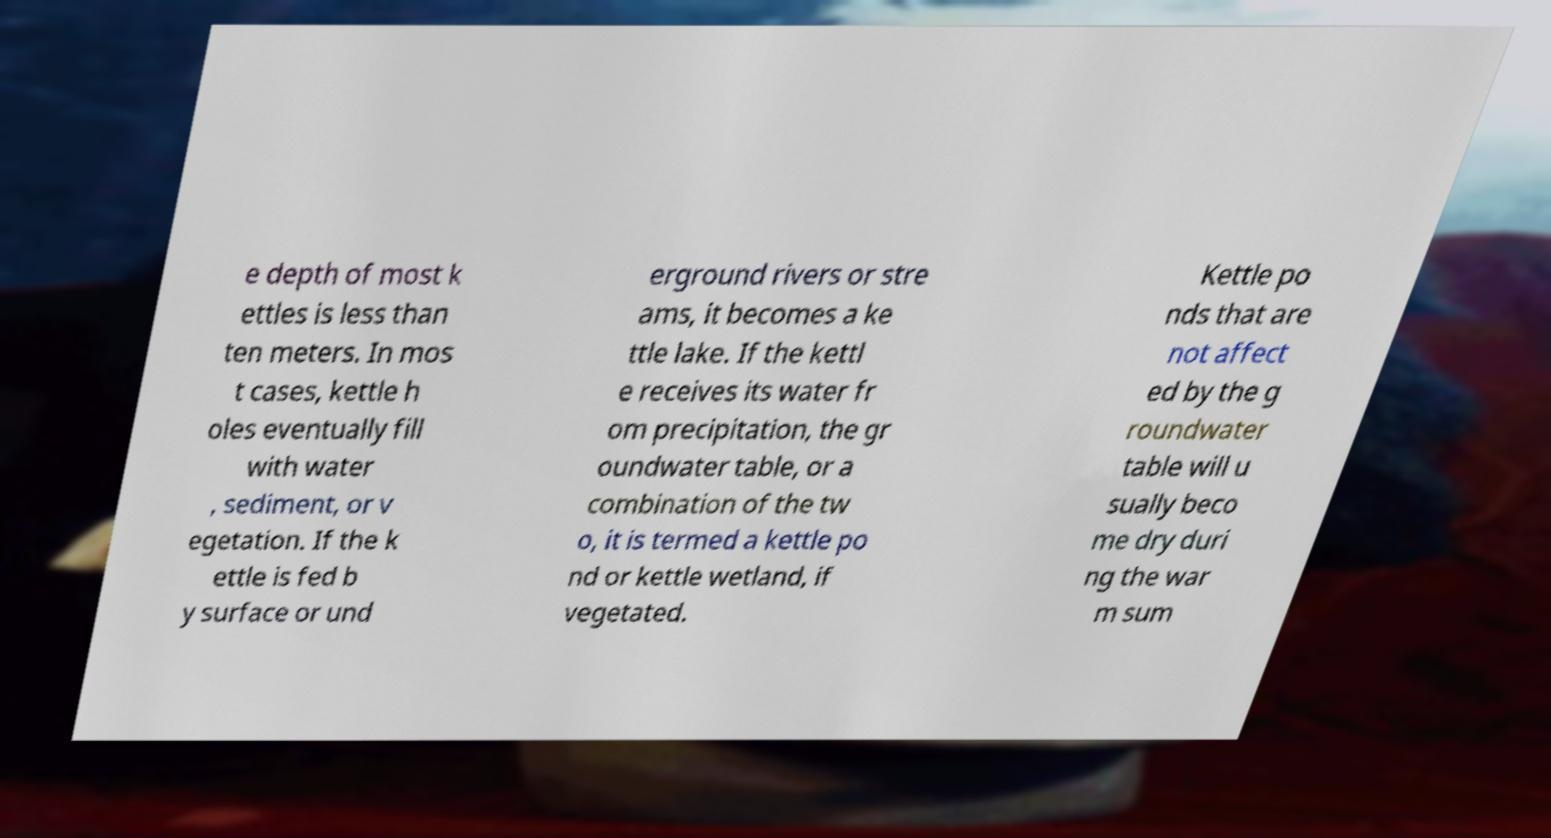Can you accurately transcribe the text from the provided image for me? e depth of most k ettles is less than ten meters. In mos t cases, kettle h oles eventually fill with water , sediment, or v egetation. If the k ettle is fed b y surface or und erground rivers or stre ams, it becomes a ke ttle lake. If the kettl e receives its water fr om precipitation, the gr oundwater table, or a combination of the tw o, it is termed a kettle po nd or kettle wetland, if vegetated. Kettle po nds that are not affect ed by the g roundwater table will u sually beco me dry duri ng the war m sum 